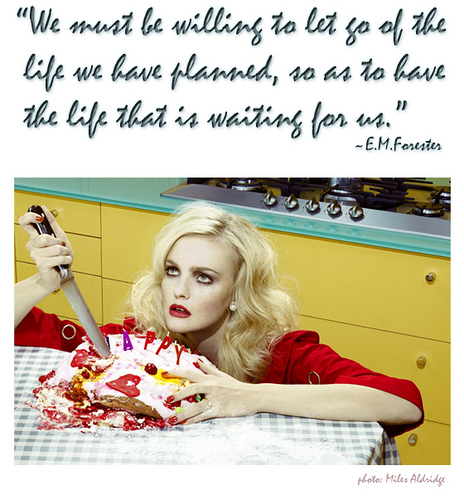Read all the text in this image. for We must us photos Aldridge Miles HAPPY E.M.Forester us waiting is that life the to planned, have we life the of go let to willing be 